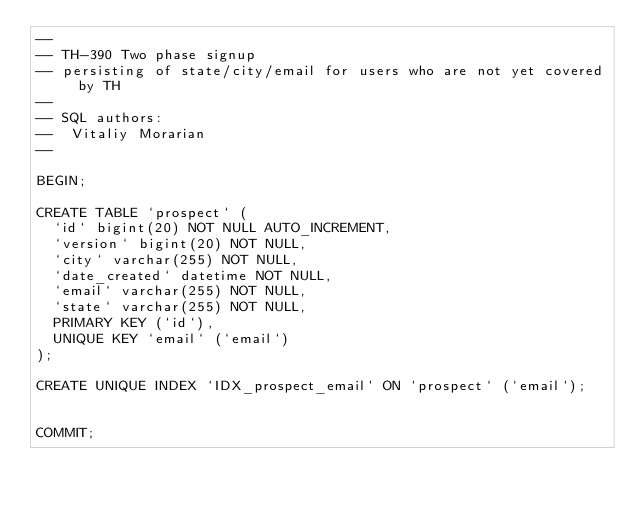Convert code to text. <code><loc_0><loc_0><loc_500><loc_500><_SQL_>--
-- TH-390 Two phase signup
-- persisting of state/city/email for users who are not yet covered by TH
--
-- SQL authors:
--  Vitaliy Morarian
-- 

BEGIN;

CREATE TABLE `prospect` (
  `id` bigint(20) NOT NULL AUTO_INCREMENT,
  `version` bigint(20) NOT NULL,
  `city` varchar(255) NOT NULL,
  `date_created` datetime NOT NULL,
  `email` varchar(255) NOT NULL,
  `state` varchar(255) NOT NULL,
  PRIMARY KEY (`id`),
  UNIQUE KEY `email` (`email`)
);

CREATE UNIQUE INDEX `IDX_prospect_email` ON `prospect` (`email`);


COMMIT;</code> 